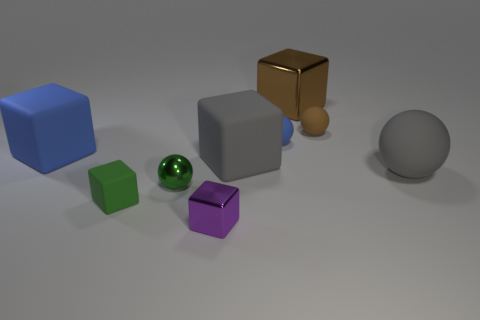Subtract 2 blocks. How many blocks are left? 3 Subtract all gray cubes. How many cubes are left? 4 Subtract all small matte blocks. How many blocks are left? 4 Subtract all cyan cubes. Subtract all cyan spheres. How many cubes are left? 5 Add 1 small yellow balls. How many objects exist? 10 Subtract all balls. How many objects are left? 5 Add 8 blue rubber objects. How many blue rubber objects exist? 10 Subtract 1 brown blocks. How many objects are left? 8 Subtract all green metallic objects. Subtract all tiny shiny cubes. How many objects are left? 7 Add 1 purple metallic objects. How many purple metallic objects are left? 2 